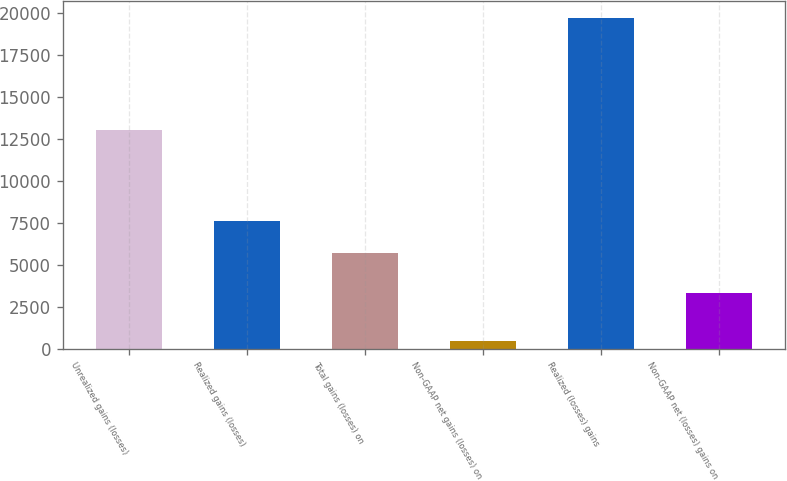<chart> <loc_0><loc_0><loc_500><loc_500><bar_chart><fcel>Unrealized gains (losses)<fcel>Realized gains (losses)<fcel>Total gains (losses) on<fcel>Non-GAAP net gains (losses) on<fcel>Realized (losses) gains<fcel>Non-GAAP net (losses) gains on<nl><fcel>13080<fcel>7662.1<fcel>5738<fcel>489<fcel>19730<fcel>3335<nl></chart> 